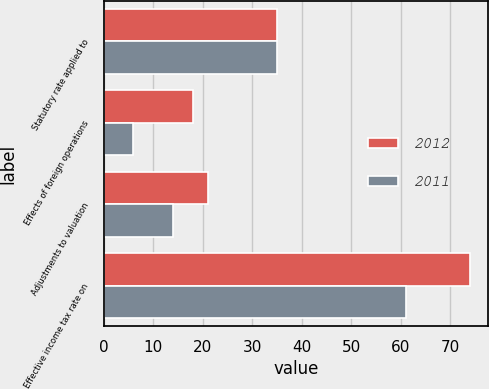Convert chart to OTSL. <chart><loc_0><loc_0><loc_500><loc_500><stacked_bar_chart><ecel><fcel>Statutory rate applied to<fcel>Effects of foreign operations<fcel>Adjustments to valuation<fcel>Effective income tax rate on<nl><fcel>2012<fcel>35<fcel>18<fcel>21<fcel>74<nl><fcel>2011<fcel>35<fcel>6<fcel>14<fcel>61<nl></chart> 